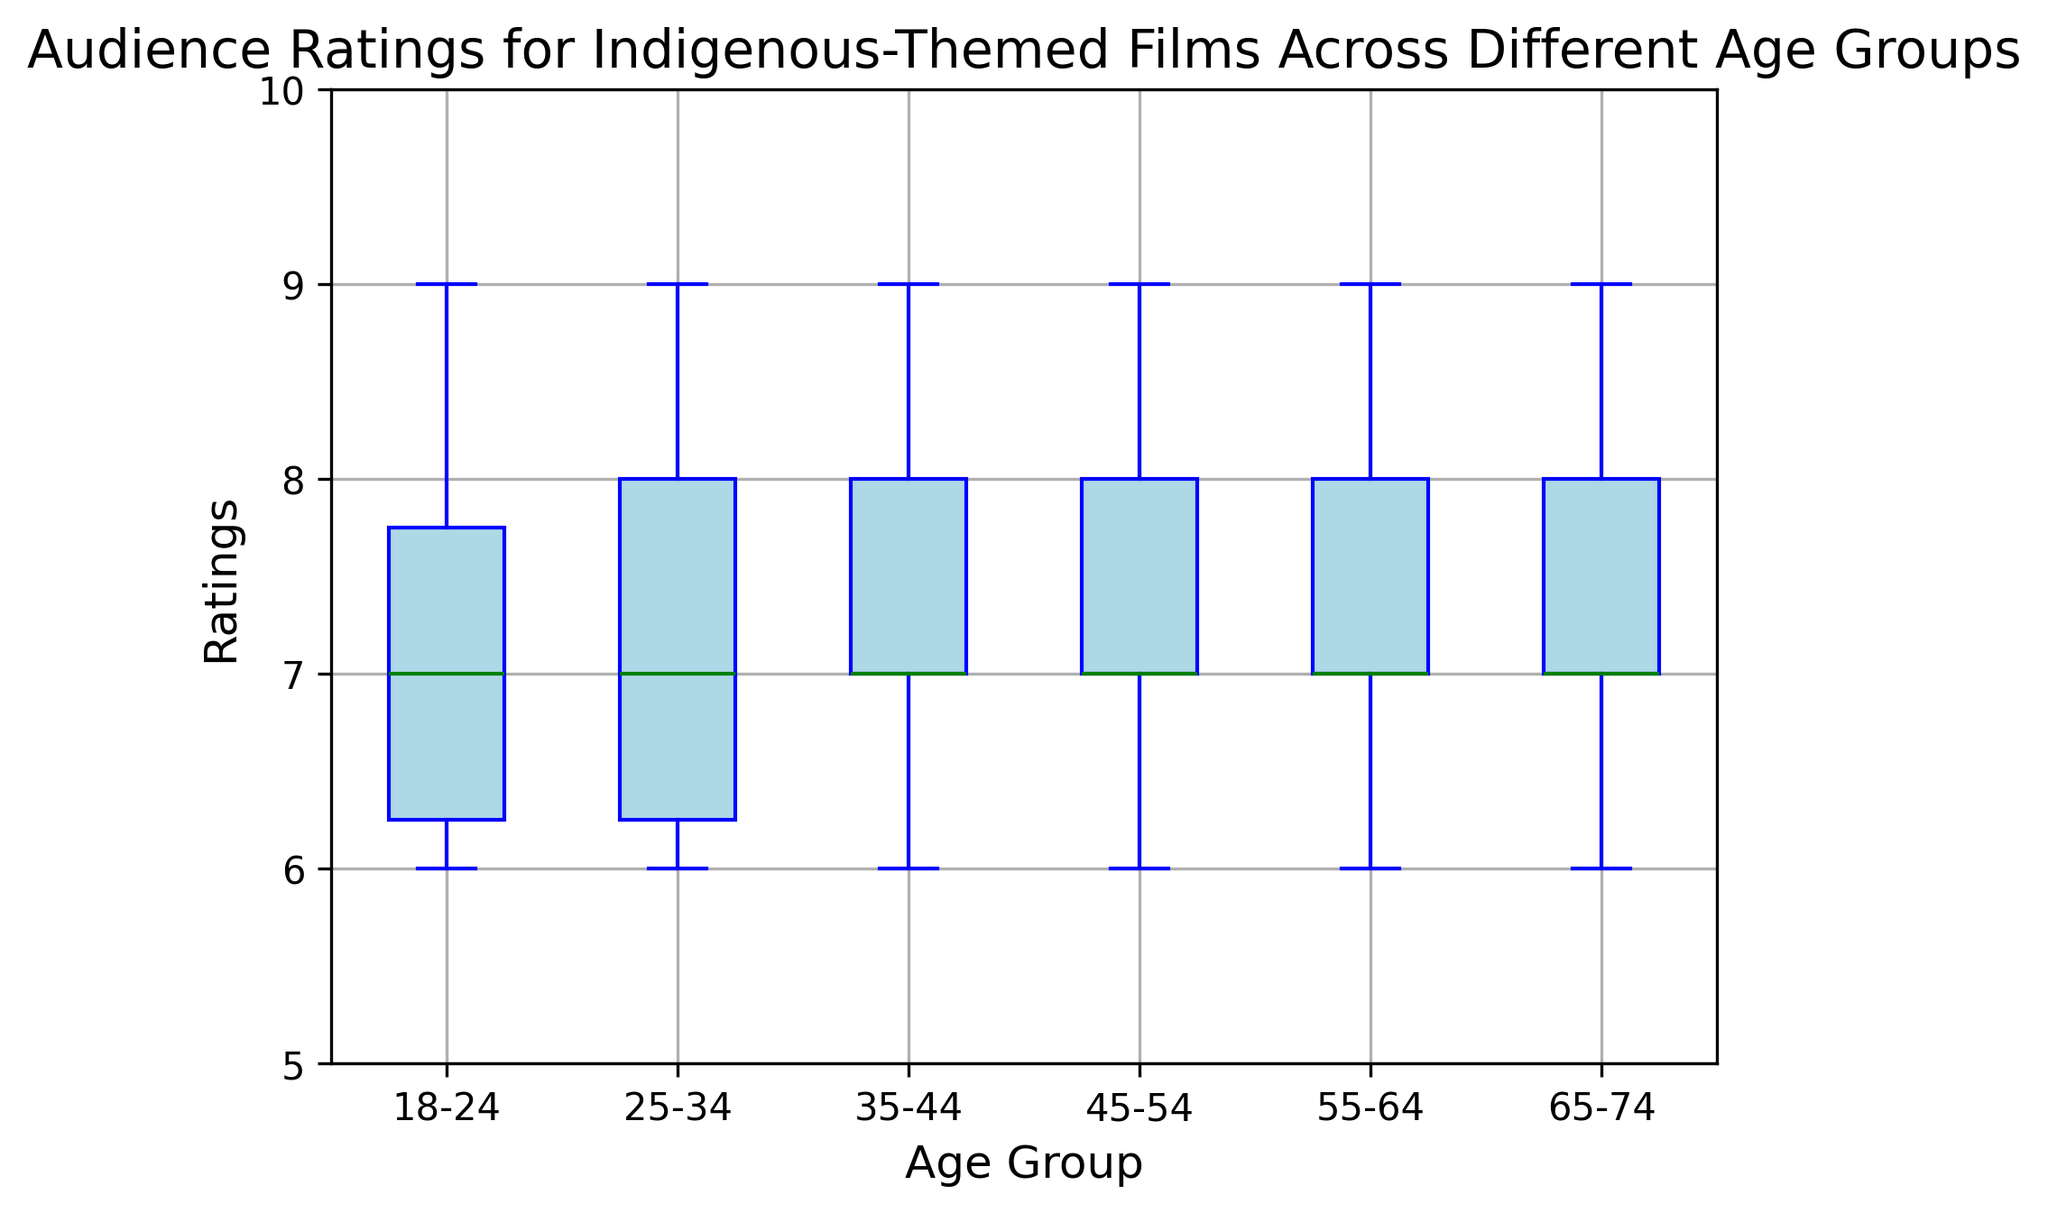Which age group has the highest median rating? The median rating is the middle value when the ratings are ordered. By looking at the central line in each box, we see that the 45-54, 55-64, and 65-74 age groups all have the highest median ratings of 7.5.
Answer: 45-54, 55-64, 65-74 What's the interquartile range (IQR) for the 18-24 age group? The IQR is the difference between the third quartile (Q3) and the first quartile (Q1). For the 18-24 group, Q3 is roughly 8 and Q1 is around 6. The IQR is 8 - 6.
Answer: 2 Which age group shows the greatest range in audience ratings? The range is the difference between the maximum and minimum values. The 35-44 and 45-54 groups have the largest range, with ratings from 6 to 9.
Answer: 35-44, 45-54 Are there any outliers in the audience ratings, and if so, in which age groups? Outliers are data points that fall outside the typical range (usually shown as points outside the whiskers). There are no visible outliers in the audience ratings across all age groups.
Answer: No outliers How do the median ratings of the 25-34 age group compare to the 55-64 age group? The median is represented by the line inside each box. Both the 25-34 and 55-64 age groups have a median rating of 7.
Answer: Equal Which age groups have ratings that vary the least? Variation is typically indicated by the length of the box. The 18-24 and 25-34 age groups have the shortest boxes, indicating the least variation.
Answer: 18-24, 25-34 What's the approximate maximum rating in the 65-74 age group? The maximum rating is shown by the top end of the whisker. For the 65-74 group, the maximum rating is approximately 9.
Answer: 9 How does the interquartile range (IQR) of the 35-44 group compare to that of the 45-54 group? The IQR is the distance between Q3 and Q1. By visually inspecting, the IQRs for the 35-44 and 45-54 groups look similar. Both have a spread from roughly 6.5 to 8.5.
Answer: Similar Which age group has the lowest minimum rating? The minimum rating is shown by the bottom end of the whisker. All age groups have a minimum rating of 6.
Answer: All groups 